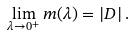<formula> <loc_0><loc_0><loc_500><loc_500>\lim _ { \lambda \to 0 ^ { + } } m ( \lambda ) = \left | D \right | .</formula> 